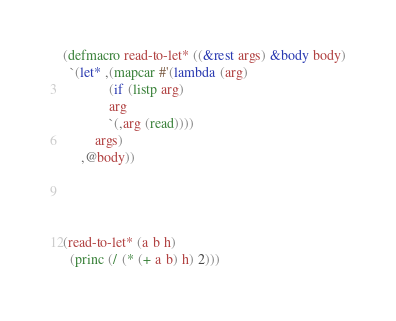Convert code to text. <code><loc_0><loc_0><loc_500><loc_500><_Lisp_>(defmacro read-to-let* ((&rest args) &body body)
  `(let* ,(mapcar #'(lambda (arg)
		     (if (listp arg)
			 arg
			 `(,arg (read))))
		 args)
     ,@body))

       


(read-to-let* (a b h)
  (princ (/ (* (+ a b) h) 2)))</code> 